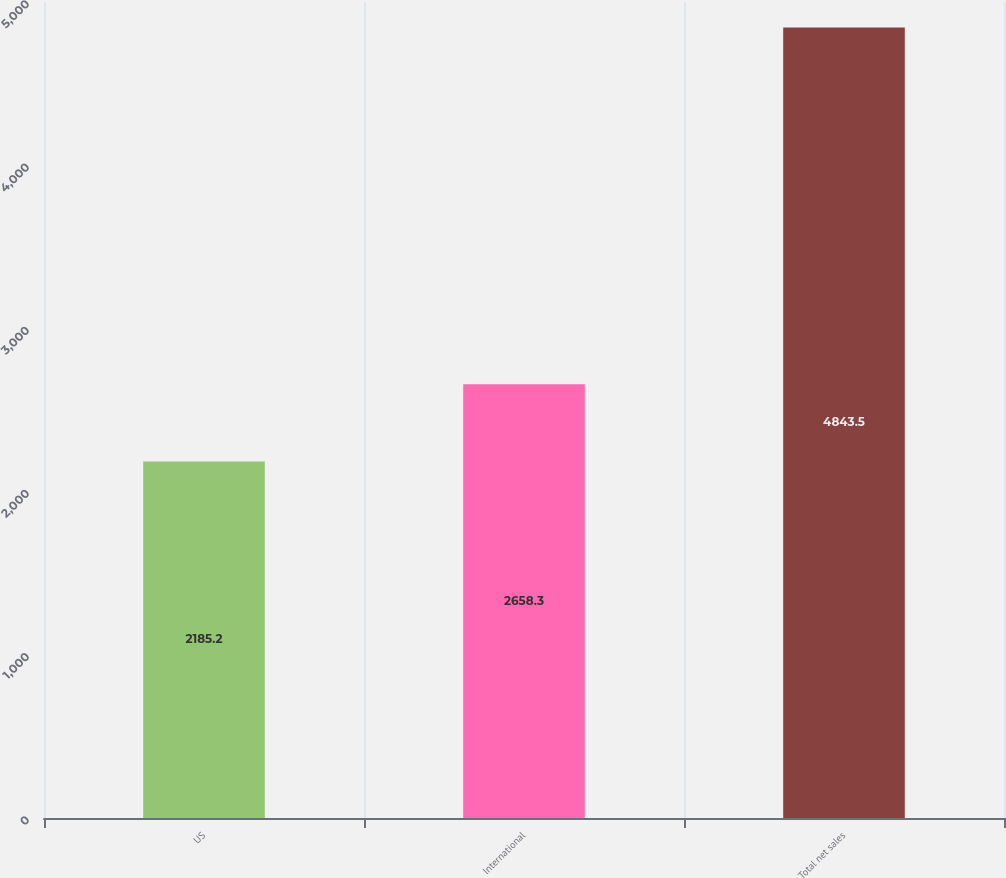Convert chart to OTSL. <chart><loc_0><loc_0><loc_500><loc_500><bar_chart><fcel>US<fcel>International<fcel>Total net sales<nl><fcel>2185.2<fcel>2658.3<fcel>4843.5<nl></chart> 